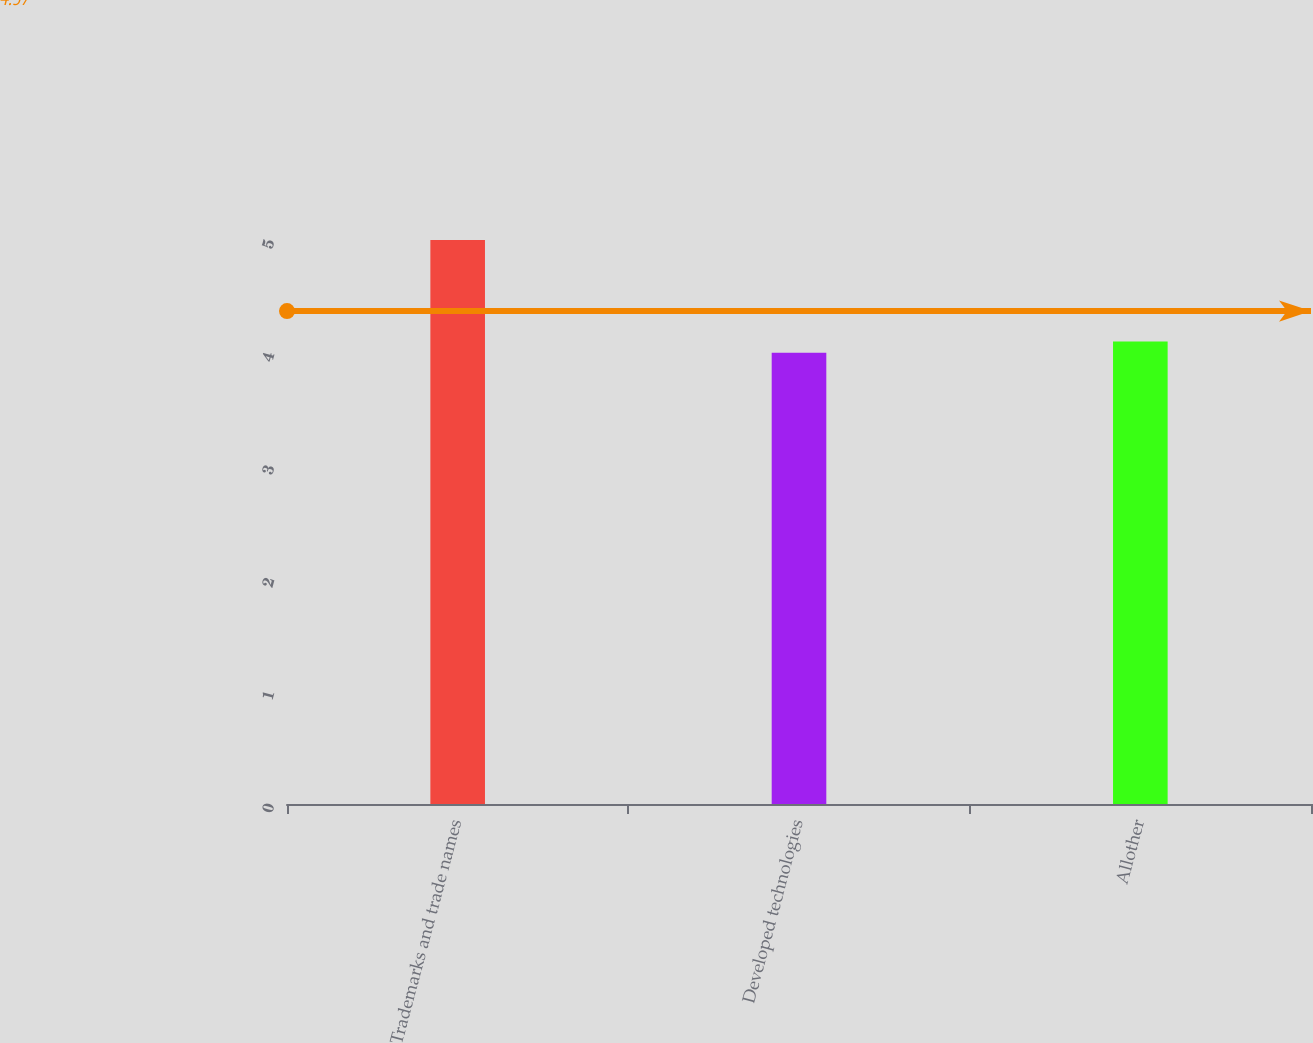<chart> <loc_0><loc_0><loc_500><loc_500><bar_chart><fcel>Trademarks and trade names<fcel>Developed technologies<fcel>Allother<nl><fcel>5<fcel>4<fcel>4.1<nl></chart> 